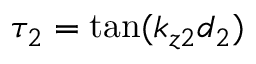<formula> <loc_0><loc_0><loc_500><loc_500>\tau _ { 2 } = \tan ( k _ { z 2 } d _ { 2 } )</formula> 